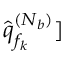Convert formula to latex. <formula><loc_0><loc_0><loc_500><loc_500>\hat { \boldsymbol q } _ { f _ { k } } ^ { ( N _ { b } ) } ]</formula> 